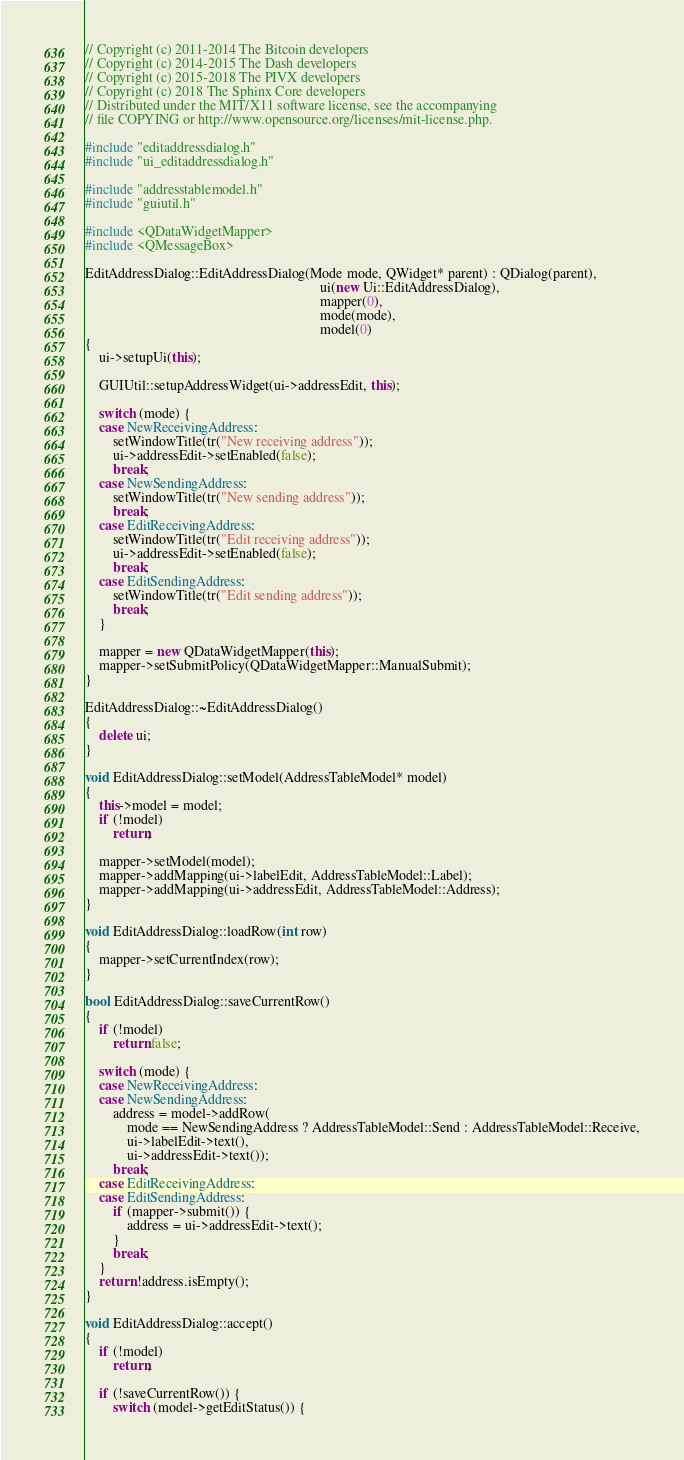Convert code to text. <code><loc_0><loc_0><loc_500><loc_500><_C++_>// Copyright (c) 2011-2014 The Bitcoin developers
// Copyright (c) 2014-2015 The Dash developers
// Copyright (c) 2015-2018 The PIVX developers
// Copyright (c) 2018 The Sphinx Core developers
// Distributed under the MIT/X11 software license, see the accompanying
// file COPYING or http://www.opensource.org/licenses/mit-license.php.

#include "editaddressdialog.h"
#include "ui_editaddressdialog.h"

#include "addresstablemodel.h"
#include "guiutil.h"

#include <QDataWidgetMapper>
#include <QMessageBox>

EditAddressDialog::EditAddressDialog(Mode mode, QWidget* parent) : QDialog(parent),
                                                                   ui(new Ui::EditAddressDialog),
                                                                   mapper(0),
                                                                   mode(mode),
                                                                   model(0)
{
    ui->setupUi(this);

    GUIUtil::setupAddressWidget(ui->addressEdit, this);

    switch (mode) {
    case NewReceivingAddress:
        setWindowTitle(tr("New receiving address"));
        ui->addressEdit->setEnabled(false);
        break;
    case NewSendingAddress:
        setWindowTitle(tr("New sending address"));
        break;
    case EditReceivingAddress:
        setWindowTitle(tr("Edit receiving address"));
        ui->addressEdit->setEnabled(false);
        break;
    case EditSendingAddress:
        setWindowTitle(tr("Edit sending address"));
        break;
    }

    mapper = new QDataWidgetMapper(this);
    mapper->setSubmitPolicy(QDataWidgetMapper::ManualSubmit);
}

EditAddressDialog::~EditAddressDialog()
{
    delete ui;
}

void EditAddressDialog::setModel(AddressTableModel* model)
{
    this->model = model;
    if (!model)
        return;

    mapper->setModel(model);
    mapper->addMapping(ui->labelEdit, AddressTableModel::Label);
    mapper->addMapping(ui->addressEdit, AddressTableModel::Address);
}

void EditAddressDialog::loadRow(int row)
{
    mapper->setCurrentIndex(row);
}

bool EditAddressDialog::saveCurrentRow()
{
    if (!model)
        return false;

    switch (mode) {
    case NewReceivingAddress:
    case NewSendingAddress:
        address = model->addRow(
            mode == NewSendingAddress ? AddressTableModel::Send : AddressTableModel::Receive,
            ui->labelEdit->text(),
            ui->addressEdit->text());
        break;
    case EditReceivingAddress:
    case EditSendingAddress:
        if (mapper->submit()) {
            address = ui->addressEdit->text();
        }
        break;
    }
    return !address.isEmpty();
}

void EditAddressDialog::accept()
{
    if (!model)
        return;

    if (!saveCurrentRow()) {
        switch (model->getEditStatus()) {</code> 